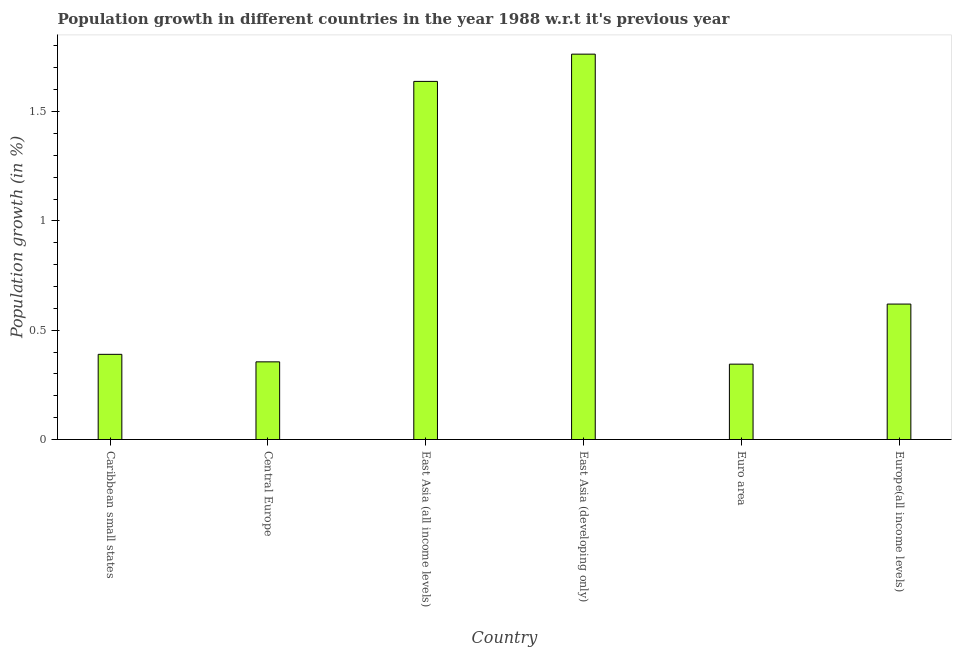What is the title of the graph?
Ensure brevity in your answer.  Population growth in different countries in the year 1988 w.r.t it's previous year. What is the label or title of the Y-axis?
Make the answer very short. Population growth (in %). What is the population growth in East Asia (developing only)?
Your answer should be compact. 1.76. Across all countries, what is the maximum population growth?
Provide a short and direct response. 1.76. Across all countries, what is the minimum population growth?
Offer a terse response. 0.34. In which country was the population growth maximum?
Make the answer very short. East Asia (developing only). What is the sum of the population growth?
Your response must be concise. 5.11. What is the difference between the population growth in Euro area and Europe(all income levels)?
Your response must be concise. -0.28. What is the average population growth per country?
Make the answer very short. 0.85. What is the median population growth?
Offer a terse response. 0.5. In how many countries, is the population growth greater than 0.5 %?
Make the answer very short. 3. What is the ratio of the population growth in East Asia (developing only) to that in Euro area?
Ensure brevity in your answer.  5.11. Is the difference between the population growth in East Asia (all income levels) and Euro area greater than the difference between any two countries?
Your answer should be compact. No. What is the difference between the highest and the second highest population growth?
Your answer should be very brief. 0.12. Is the sum of the population growth in Central Europe and Euro area greater than the maximum population growth across all countries?
Your answer should be very brief. No. What is the difference between the highest and the lowest population growth?
Offer a very short reply. 1.42. Are all the bars in the graph horizontal?
Give a very brief answer. No. How many countries are there in the graph?
Your response must be concise. 6. What is the difference between two consecutive major ticks on the Y-axis?
Keep it short and to the point. 0.5. What is the Population growth (in %) of Caribbean small states?
Offer a terse response. 0.39. What is the Population growth (in %) of Central Europe?
Provide a succinct answer. 0.36. What is the Population growth (in %) of East Asia (all income levels)?
Keep it short and to the point. 1.64. What is the Population growth (in %) of East Asia (developing only)?
Your answer should be very brief. 1.76. What is the Population growth (in %) of Euro area?
Give a very brief answer. 0.34. What is the Population growth (in %) of Europe(all income levels)?
Keep it short and to the point. 0.62. What is the difference between the Population growth (in %) in Caribbean small states and Central Europe?
Your answer should be compact. 0.03. What is the difference between the Population growth (in %) in Caribbean small states and East Asia (all income levels)?
Ensure brevity in your answer.  -1.25. What is the difference between the Population growth (in %) in Caribbean small states and East Asia (developing only)?
Your response must be concise. -1.37. What is the difference between the Population growth (in %) in Caribbean small states and Euro area?
Your response must be concise. 0.04. What is the difference between the Population growth (in %) in Caribbean small states and Europe(all income levels)?
Provide a succinct answer. -0.23. What is the difference between the Population growth (in %) in Central Europe and East Asia (all income levels)?
Your response must be concise. -1.28. What is the difference between the Population growth (in %) in Central Europe and East Asia (developing only)?
Keep it short and to the point. -1.41. What is the difference between the Population growth (in %) in Central Europe and Euro area?
Give a very brief answer. 0.01. What is the difference between the Population growth (in %) in Central Europe and Europe(all income levels)?
Keep it short and to the point. -0.26. What is the difference between the Population growth (in %) in East Asia (all income levels) and East Asia (developing only)?
Offer a terse response. -0.12. What is the difference between the Population growth (in %) in East Asia (all income levels) and Euro area?
Provide a short and direct response. 1.29. What is the difference between the Population growth (in %) in East Asia (all income levels) and Europe(all income levels)?
Provide a succinct answer. 1.02. What is the difference between the Population growth (in %) in East Asia (developing only) and Euro area?
Ensure brevity in your answer.  1.42. What is the difference between the Population growth (in %) in East Asia (developing only) and Europe(all income levels)?
Give a very brief answer. 1.14. What is the difference between the Population growth (in %) in Euro area and Europe(all income levels)?
Your answer should be very brief. -0.27. What is the ratio of the Population growth (in %) in Caribbean small states to that in Central Europe?
Give a very brief answer. 1.1. What is the ratio of the Population growth (in %) in Caribbean small states to that in East Asia (all income levels)?
Provide a succinct answer. 0.24. What is the ratio of the Population growth (in %) in Caribbean small states to that in East Asia (developing only)?
Offer a very short reply. 0.22. What is the ratio of the Population growth (in %) in Caribbean small states to that in Euro area?
Your answer should be compact. 1.13. What is the ratio of the Population growth (in %) in Caribbean small states to that in Europe(all income levels)?
Your answer should be compact. 0.63. What is the ratio of the Population growth (in %) in Central Europe to that in East Asia (all income levels)?
Your response must be concise. 0.22. What is the ratio of the Population growth (in %) in Central Europe to that in East Asia (developing only)?
Your answer should be compact. 0.2. What is the ratio of the Population growth (in %) in Central Europe to that in Euro area?
Offer a very short reply. 1.03. What is the ratio of the Population growth (in %) in Central Europe to that in Europe(all income levels)?
Your answer should be very brief. 0.57. What is the ratio of the Population growth (in %) in East Asia (all income levels) to that in East Asia (developing only)?
Your answer should be very brief. 0.93. What is the ratio of the Population growth (in %) in East Asia (all income levels) to that in Euro area?
Offer a very short reply. 4.75. What is the ratio of the Population growth (in %) in East Asia (all income levels) to that in Europe(all income levels)?
Provide a short and direct response. 2.64. What is the ratio of the Population growth (in %) in East Asia (developing only) to that in Euro area?
Your response must be concise. 5.11. What is the ratio of the Population growth (in %) in East Asia (developing only) to that in Europe(all income levels)?
Provide a succinct answer. 2.85. What is the ratio of the Population growth (in %) in Euro area to that in Europe(all income levels)?
Provide a short and direct response. 0.56. 